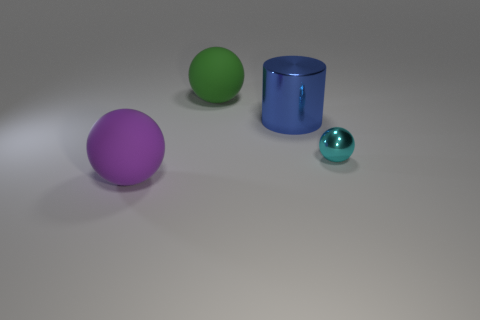Are the objects casting any shadows, and if so, what does that tell us about the light source? Yes, each object casts a soft shadow suggesting a diffuse, probably overhead light source. The shadow's angle indicates the light is coming from the upper left side of the frame. 